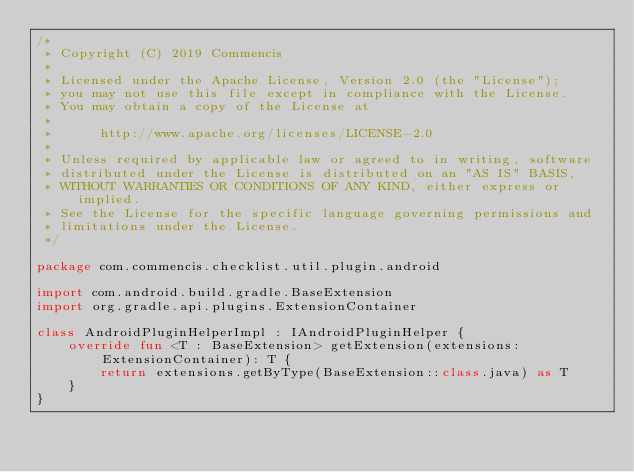<code> <loc_0><loc_0><loc_500><loc_500><_Kotlin_>/*
 * Copyright (C) 2019 Commencis
 *
 * Licensed under the Apache License, Version 2.0 (the "License");
 * you may not use this file except in compliance with the License.
 * You may obtain a copy of the License at
 *
 *      http://www.apache.org/licenses/LICENSE-2.0
 *
 * Unless required by applicable law or agreed to in writing, software
 * distributed under the License is distributed on an "AS IS" BASIS,
 * WITHOUT WARRANTIES OR CONDITIONS OF ANY KIND, either express or implied.
 * See the License for the specific language governing permissions and
 * limitations under the License.
 */

package com.commencis.checklist.util.plugin.android

import com.android.build.gradle.BaseExtension
import org.gradle.api.plugins.ExtensionContainer

class AndroidPluginHelperImpl : IAndroidPluginHelper {
    override fun <T : BaseExtension> getExtension(extensions: ExtensionContainer): T {
        return extensions.getByType(BaseExtension::class.java) as T
    }
}</code> 